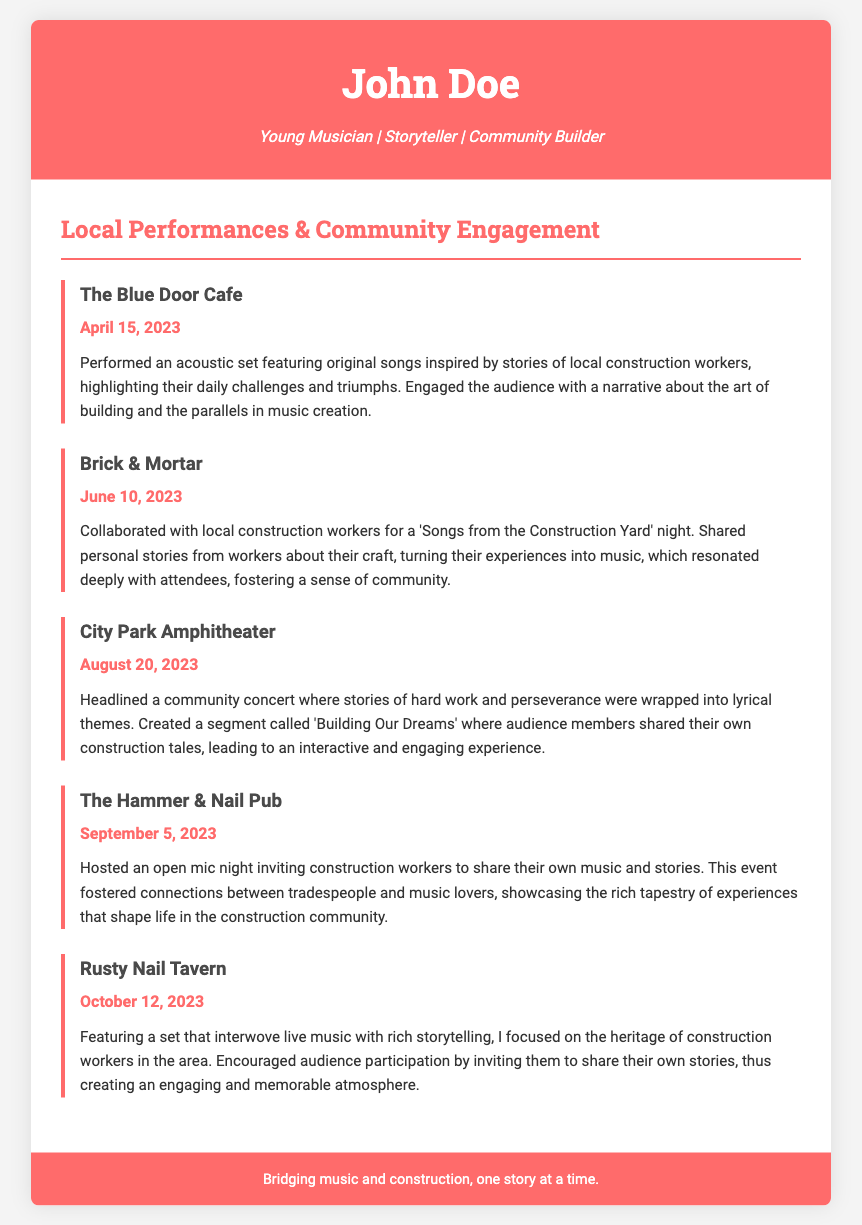What is the name of the musician? The name is prominently displayed in the header section of the document.
Answer: John Doe When did the performance at The Blue Door Cafe take place? The performance date is listed directly below the venue name in the performance section.
Answer: April 15, 2023 What was the theme of the concert at City Park Amphitheater? The theme is mentioned in the performance description for that venue.
Answer: Building Our Dreams Which venue hosted an open mic night? The specific venue is clearly stated in the performance section where the event is described.
Answer: The Hammer & Nail Pub How many performances are listed in total? The total number is determined by counting the performance sections included in the main body.
Answer: Five What is the significance of the performance descriptions? The descriptions highlight the musician's connection with the construction community and audience engagement.
Answer: They emphasize connections with the construction community What type of event was held at Brick & Mortar? The event type is described in the performance section for that specific venue.
Answer: 'Songs from the Construction Yard' night How does the musician engage the audience? Engagement methods are outlined in each performance description, focusing on storytelling and participation.
Answer: Through storytelling and inviting audience participation What overarching theme connects the performances? The common thread is inferred from the descriptions of various performances relating to experiences in construction.
Answer: Stories of construction workers 